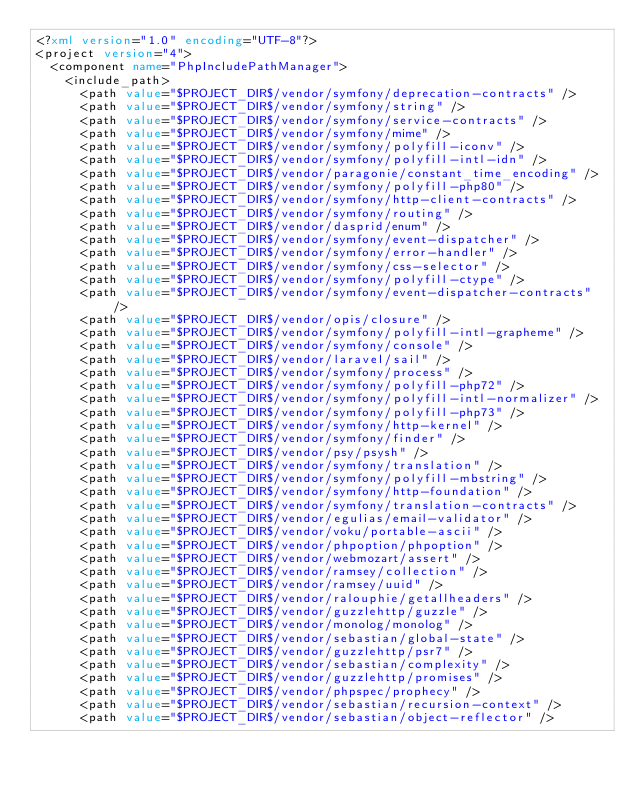Convert code to text. <code><loc_0><loc_0><loc_500><loc_500><_XML_><?xml version="1.0" encoding="UTF-8"?>
<project version="4">
  <component name="PhpIncludePathManager">
    <include_path>
      <path value="$PROJECT_DIR$/vendor/symfony/deprecation-contracts" />
      <path value="$PROJECT_DIR$/vendor/symfony/string" />
      <path value="$PROJECT_DIR$/vendor/symfony/service-contracts" />
      <path value="$PROJECT_DIR$/vendor/symfony/mime" />
      <path value="$PROJECT_DIR$/vendor/symfony/polyfill-iconv" />
      <path value="$PROJECT_DIR$/vendor/symfony/polyfill-intl-idn" />
      <path value="$PROJECT_DIR$/vendor/paragonie/constant_time_encoding" />
      <path value="$PROJECT_DIR$/vendor/symfony/polyfill-php80" />
      <path value="$PROJECT_DIR$/vendor/symfony/http-client-contracts" />
      <path value="$PROJECT_DIR$/vendor/symfony/routing" />
      <path value="$PROJECT_DIR$/vendor/dasprid/enum" />
      <path value="$PROJECT_DIR$/vendor/symfony/event-dispatcher" />
      <path value="$PROJECT_DIR$/vendor/symfony/error-handler" />
      <path value="$PROJECT_DIR$/vendor/symfony/css-selector" />
      <path value="$PROJECT_DIR$/vendor/symfony/polyfill-ctype" />
      <path value="$PROJECT_DIR$/vendor/symfony/event-dispatcher-contracts" />
      <path value="$PROJECT_DIR$/vendor/opis/closure" />
      <path value="$PROJECT_DIR$/vendor/symfony/polyfill-intl-grapheme" />
      <path value="$PROJECT_DIR$/vendor/symfony/console" />
      <path value="$PROJECT_DIR$/vendor/laravel/sail" />
      <path value="$PROJECT_DIR$/vendor/symfony/process" />
      <path value="$PROJECT_DIR$/vendor/symfony/polyfill-php72" />
      <path value="$PROJECT_DIR$/vendor/symfony/polyfill-intl-normalizer" />
      <path value="$PROJECT_DIR$/vendor/symfony/polyfill-php73" />
      <path value="$PROJECT_DIR$/vendor/symfony/http-kernel" />
      <path value="$PROJECT_DIR$/vendor/symfony/finder" />
      <path value="$PROJECT_DIR$/vendor/psy/psysh" />
      <path value="$PROJECT_DIR$/vendor/symfony/translation" />
      <path value="$PROJECT_DIR$/vendor/symfony/polyfill-mbstring" />
      <path value="$PROJECT_DIR$/vendor/symfony/http-foundation" />
      <path value="$PROJECT_DIR$/vendor/symfony/translation-contracts" />
      <path value="$PROJECT_DIR$/vendor/egulias/email-validator" />
      <path value="$PROJECT_DIR$/vendor/voku/portable-ascii" />
      <path value="$PROJECT_DIR$/vendor/phpoption/phpoption" />
      <path value="$PROJECT_DIR$/vendor/webmozart/assert" />
      <path value="$PROJECT_DIR$/vendor/ramsey/collection" />
      <path value="$PROJECT_DIR$/vendor/ramsey/uuid" />
      <path value="$PROJECT_DIR$/vendor/ralouphie/getallheaders" />
      <path value="$PROJECT_DIR$/vendor/guzzlehttp/guzzle" />
      <path value="$PROJECT_DIR$/vendor/monolog/monolog" />
      <path value="$PROJECT_DIR$/vendor/sebastian/global-state" />
      <path value="$PROJECT_DIR$/vendor/guzzlehttp/psr7" />
      <path value="$PROJECT_DIR$/vendor/sebastian/complexity" />
      <path value="$PROJECT_DIR$/vendor/guzzlehttp/promises" />
      <path value="$PROJECT_DIR$/vendor/phpspec/prophecy" />
      <path value="$PROJECT_DIR$/vendor/sebastian/recursion-context" />
      <path value="$PROJECT_DIR$/vendor/sebastian/object-reflector" /></code> 